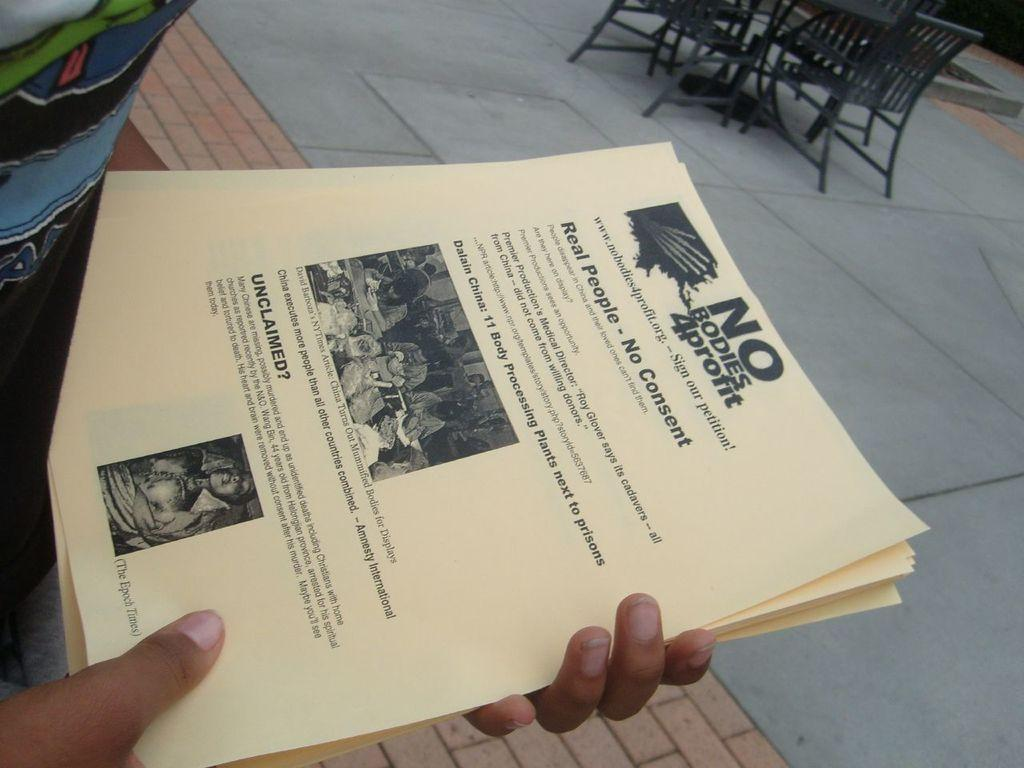What is the person in the image holding? The person is holding papers in the image. What can be seen at the bottom of the image? There is a road at the bottom of the image. Where are the chairs located in the image? The chairs are on the right side of the image. Where is the scarecrow located in the image? There is no scarecrow present in the image. What type of face can be seen on the person holding papers? The image does not show the person's face, so it cannot be determined from the image. 